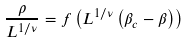Convert formula to latex. <formula><loc_0><loc_0><loc_500><loc_500>\frac { \rho } { L ^ { 1 / \nu } } = f \left ( L ^ { 1 / \nu } \left ( \beta _ { c } - \beta \right ) \right )</formula> 